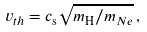<formula> <loc_0><loc_0><loc_500><loc_500>v _ { t h } = c _ { \mathrm s } \sqrt { m _ { \mathrm H } / m _ { N e } } \, ,</formula> 